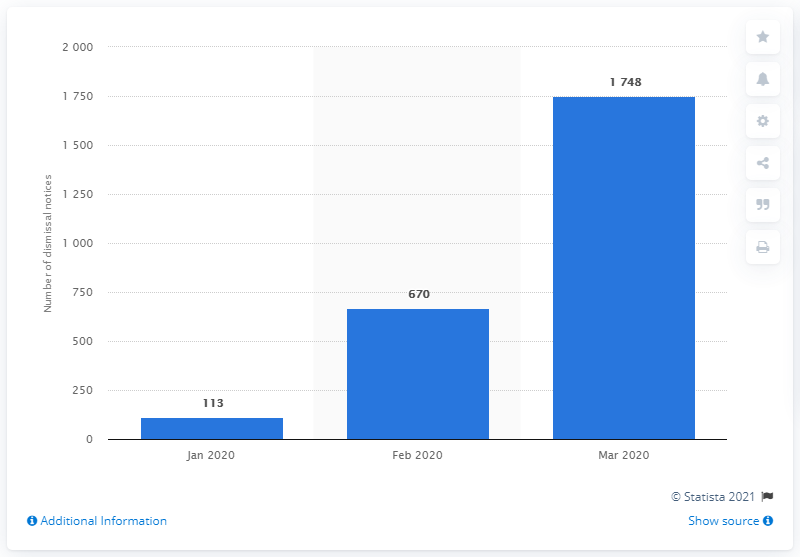Identify some key points in this picture. In January 2020, 113 employees were notified of their dismissal. 